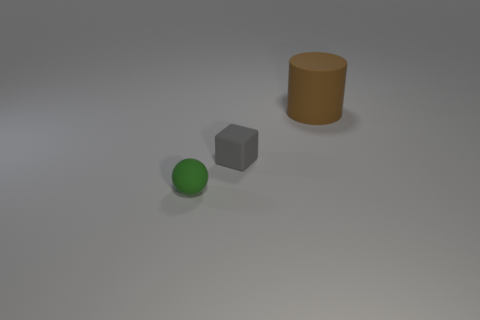Add 3 large yellow blocks. How many objects exist? 6 Subtract all cylinders. How many objects are left? 2 Subtract 0 blue blocks. How many objects are left? 3 Subtract all big gray shiny cubes. Subtract all tiny green balls. How many objects are left? 2 Add 3 small matte blocks. How many small matte blocks are left? 4 Add 3 small balls. How many small balls exist? 4 